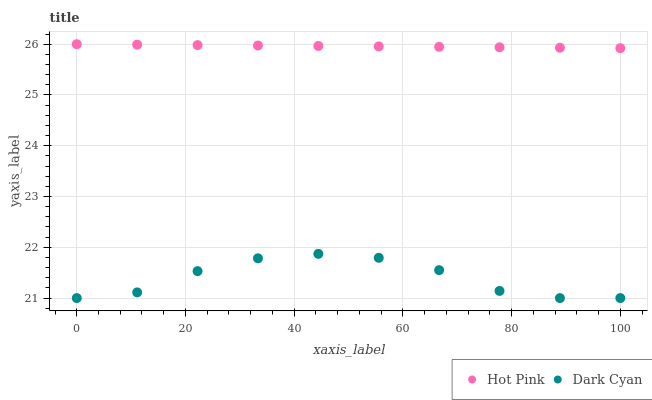Does Dark Cyan have the minimum area under the curve?
Answer yes or no. Yes. Does Hot Pink have the maximum area under the curve?
Answer yes or no. Yes. Does Hot Pink have the minimum area under the curve?
Answer yes or no. No. Is Hot Pink the smoothest?
Answer yes or no. Yes. Is Dark Cyan the roughest?
Answer yes or no. Yes. Is Hot Pink the roughest?
Answer yes or no. No. Does Dark Cyan have the lowest value?
Answer yes or no. Yes. Does Hot Pink have the lowest value?
Answer yes or no. No. Does Hot Pink have the highest value?
Answer yes or no. Yes. Is Dark Cyan less than Hot Pink?
Answer yes or no. Yes. Is Hot Pink greater than Dark Cyan?
Answer yes or no. Yes. Does Dark Cyan intersect Hot Pink?
Answer yes or no. No. 